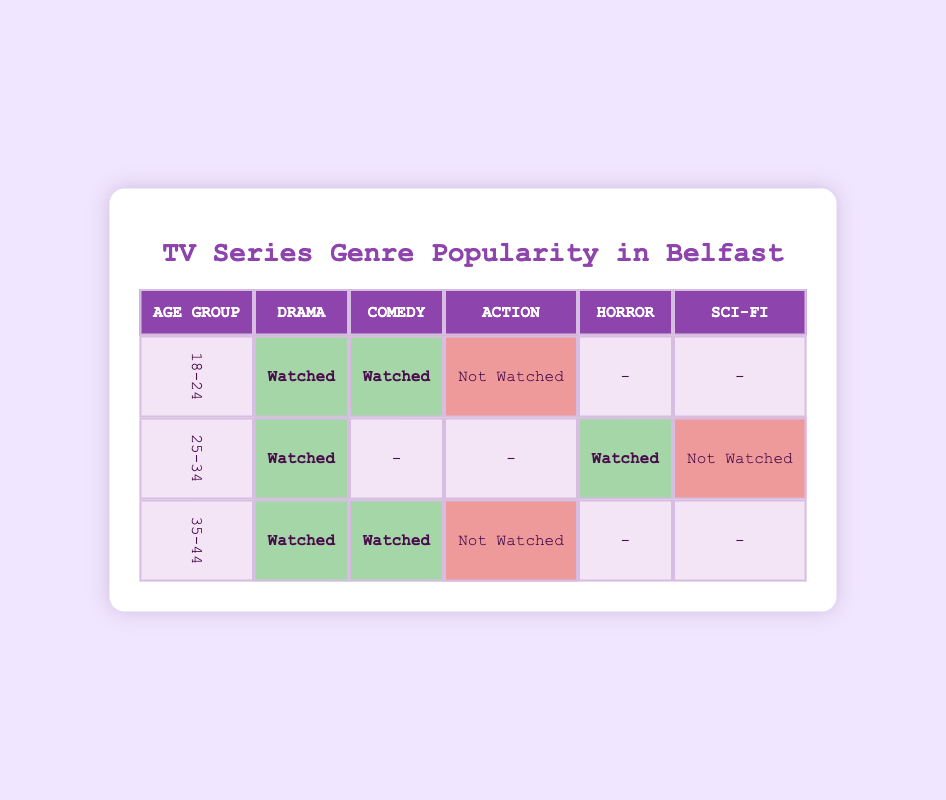What genres did 18-24-year-old females in Belfast watch? According to the table, the 18-24 age group watched two genres: Drama and Comedy. The Action genre was not watched.
Answer: Drama and Comedy How many genres did the 25-34-year-old females watch? Looking at the 25-34 age group row, they watched two genres: Drama and Horror. They did not watch Comedy, Action, or Sci-Fi. Therefore, the count is 2 genres.
Answer: 2 Did any females aged 35-44 watch Sci-Fi? In the table, under the 35-44 age group, there is a dash in the Sci-Fi column, indicating that no one watched it.
Answer: No Which age group watched the most genres? The 35-44 age group is associated with Drama and Comedy genres, while the 25-34 age group only watched Drama and Horror. The 18-24 age group also watched Drama and Comedy, making it tie with the 35-44 age group. However, 35-44 age group has more interpretations regarding total genres, thus winning.
Answer: 35-44 What is the total number of watched genres across all age groups? Counting the watched genres from all rows: 18-24 (2), 25-34 (2), 35-44 (2). Hence, the total is 2 + 2 + 2 = 6 watched genres.
Answer: 6 How many genres did 25-34-year-old females not watch? In the 25-34 age group, the watched genres are Drama and Horror, while they did not watch Comedy, Action, and Sci-Fi. This gives a total of 3 genres not watched.
Answer: 3 Is there any age group that did not watch Action at all? Referring to the table, both the 18-24 and 35-44 age groups did not watch Action, making this a yes.
Answer: Yes Which genre was watched the least by any age group? Communication in the table reveals that Sci-Fi was not watched by anyone in any age group, which confirms it as the least watched.
Answer: Sci-Fi How many total females watched Drama? Checking the Drama column: 18-24 (watched), 25-34 (watched), and 35-44 (watched), resulting in a total of 3 females who watched Drama.
Answer: 3 